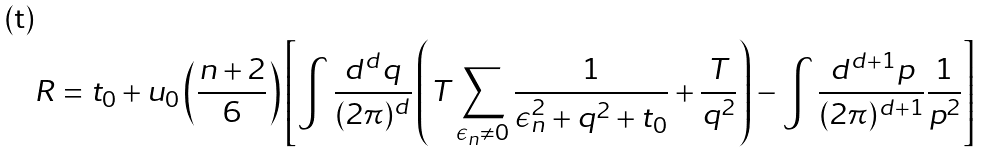Convert formula to latex. <formula><loc_0><loc_0><loc_500><loc_500>R = t _ { 0 } + u _ { 0 } \left ( \frac { n + 2 } { 6 } \right ) \left [ \int \frac { d ^ { d } q } { ( 2 \pi ) ^ { d } } \left ( T \sum _ { \epsilon _ { n } \neq 0 } \frac { 1 } { \epsilon _ { n } ^ { 2 } + q ^ { 2 } + t _ { 0 } } + \frac { T } { q ^ { 2 } } \right ) - \int \frac { d ^ { d + 1 } p } { ( 2 \pi ) ^ { d + 1 } } \frac { 1 } { p ^ { 2 } } \right ]</formula> 